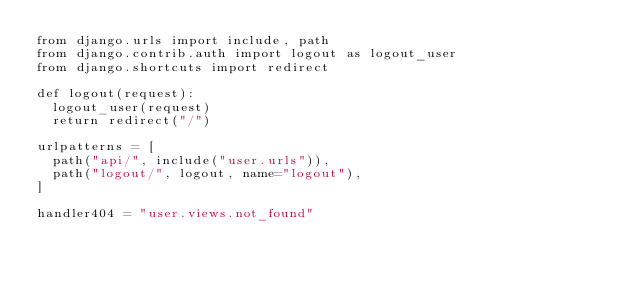<code> <loc_0><loc_0><loc_500><loc_500><_Python_>from django.urls import include, path
from django.contrib.auth import logout as logout_user
from django.shortcuts import redirect

def logout(request):
  logout_user(request)
  return redirect("/")

urlpatterns = [
  path("api/", include("user.urls")),
  path("logout/", logout, name="logout"),
]

handler404 = "user.views.not_found"
</code> 